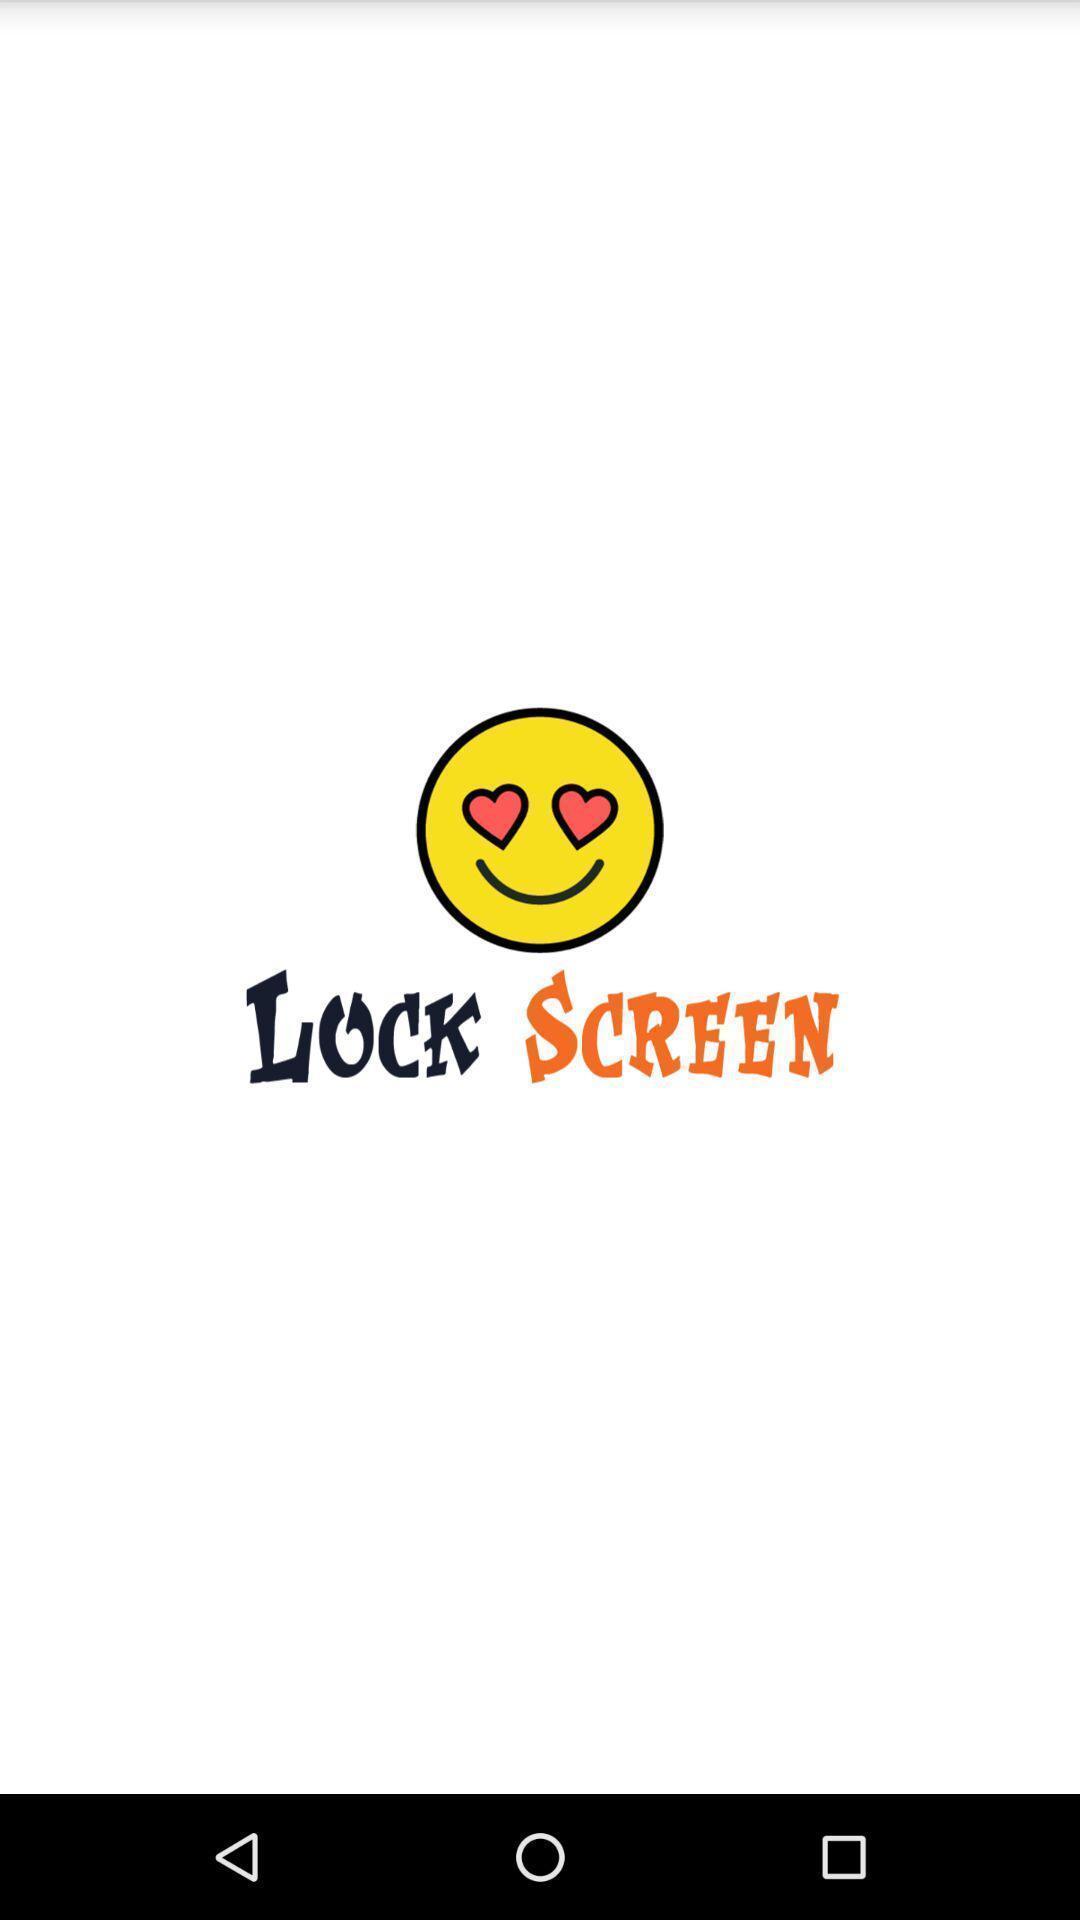Tell me what you see in this picture. Screen displaying smiley on photo lockscreen app. 